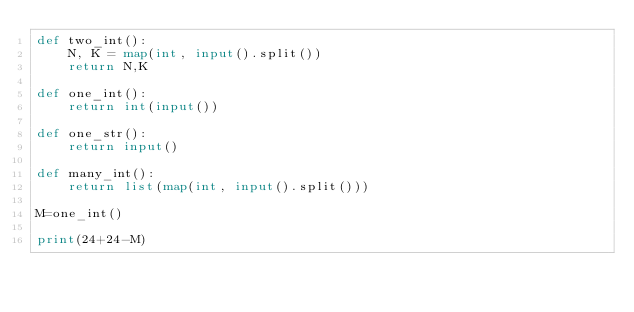<code> <loc_0><loc_0><loc_500><loc_500><_Python_>def two_int():
    N, K = map(int, input().split())
    return N,K

def one_int():
    return int(input())

def one_str():
    return input()

def many_int():
    return list(map(int, input().split()))

M=one_int()

print(24+24-M)</code> 